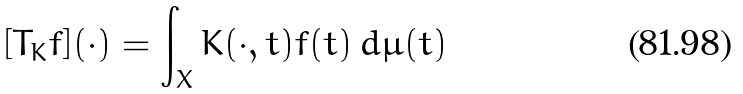Convert formula to latex. <formula><loc_0><loc_0><loc_500><loc_500>[ T _ { K } f ] ( \cdot ) = \int _ { X } K ( \cdot , t ) f ( t ) \, d \mu ( t )</formula> 